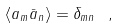Convert formula to latex. <formula><loc_0><loc_0><loc_500><loc_500>\langle a _ { m } { \bar { a } } _ { n } \rangle = \delta _ { m n } \ ,</formula> 